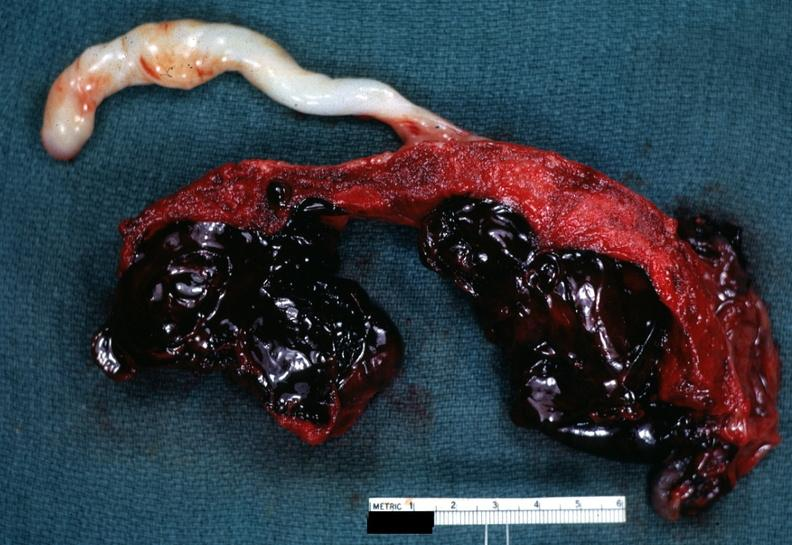s glomerulosa present?
Answer the question using a single word or phrase. No 